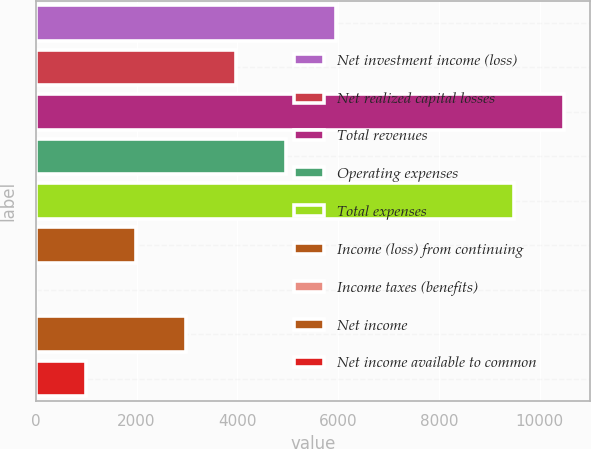<chart> <loc_0><loc_0><loc_500><loc_500><bar_chart><fcel>Net investment income (loss)<fcel>Net realized capital losses<fcel>Total revenues<fcel>Operating expenses<fcel>Total expenses<fcel>Income (loss) from continuing<fcel>Income taxes (benefits)<fcel>Net income<fcel>Net income available to common<nl><fcel>5963.34<fcel>3977.06<fcel>10475.4<fcel>4970.2<fcel>9482.3<fcel>1990.78<fcel>4.5<fcel>2983.92<fcel>997.64<nl></chart> 